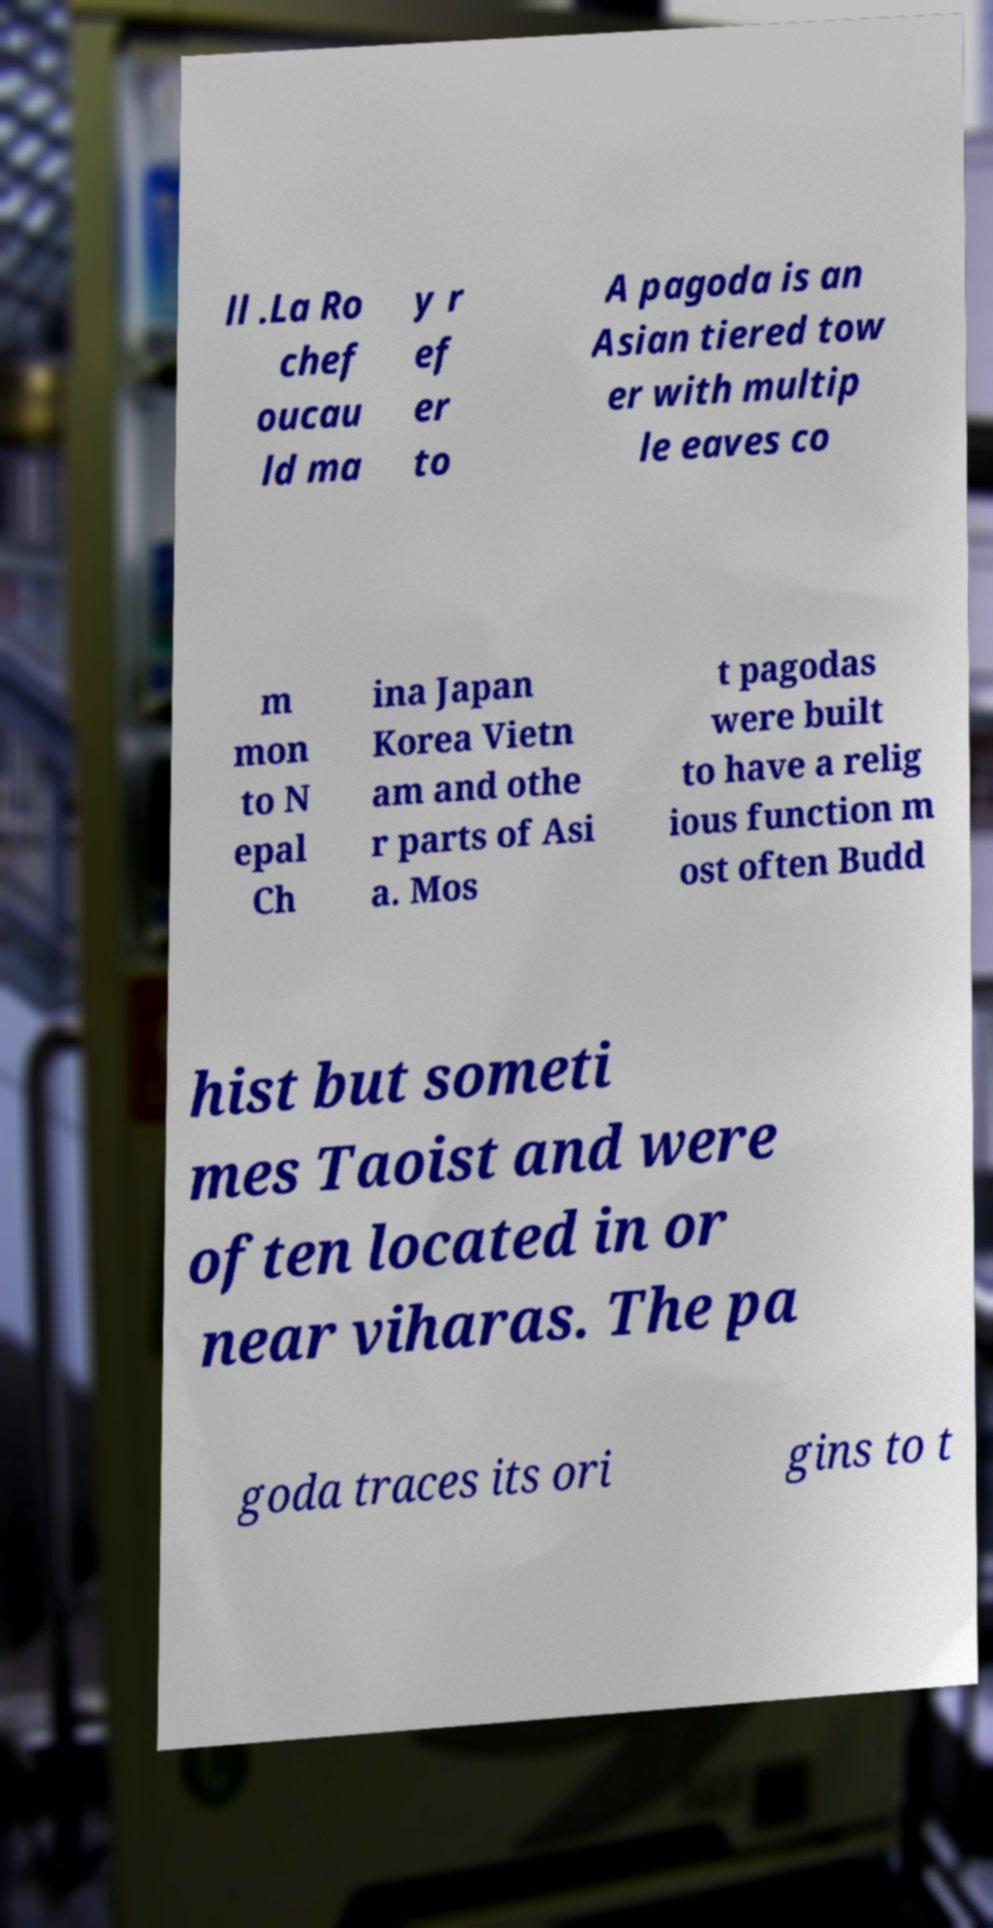Please identify and transcribe the text found in this image. ll .La Ro chef oucau ld ma y r ef er to A pagoda is an Asian tiered tow er with multip le eaves co m mon to N epal Ch ina Japan Korea Vietn am and othe r parts of Asi a. Mos t pagodas were built to have a relig ious function m ost often Budd hist but someti mes Taoist and were often located in or near viharas. The pa goda traces its ori gins to t 